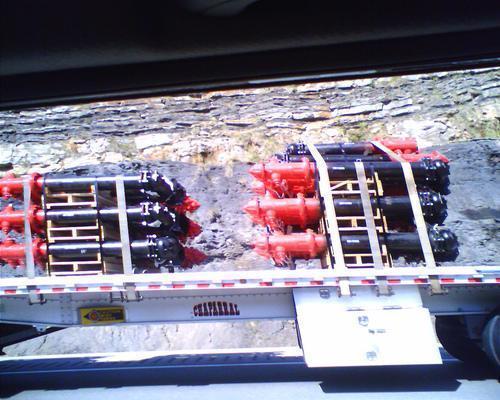How many fire hydrants are in the photo?
Give a very brief answer. 3. 